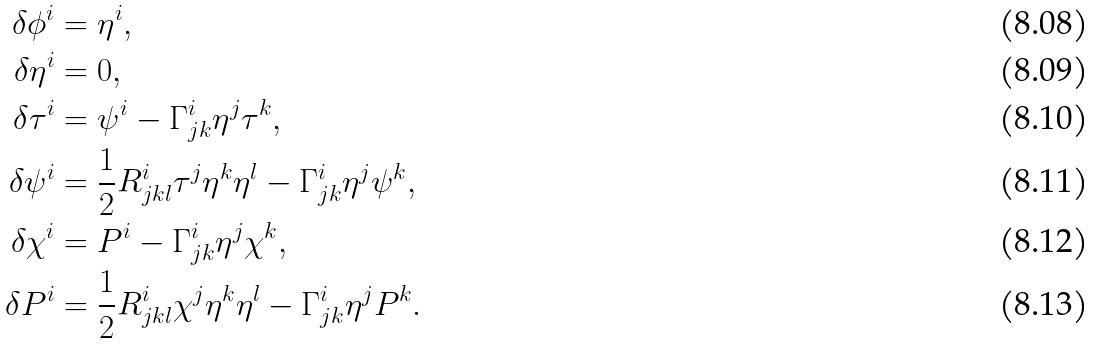<formula> <loc_0><loc_0><loc_500><loc_500>\delta \phi ^ { i } & = \eta ^ { i } , \\ \delta \eta ^ { i } & = 0 , \\ \delta \tau ^ { i } & = \psi ^ { i } - \Gamma ^ { i } _ { j k } \eta ^ { j } \tau ^ { k } , \\ \delta \psi ^ { i } & = \frac { 1 } { 2 } R ^ { i } _ { j k l } \tau ^ { j } \eta ^ { k } \eta ^ { l } - \Gamma ^ { i } _ { j k } \eta ^ { j } \psi ^ { k } , \\ \delta \chi ^ { i } & = P ^ { i } - \Gamma ^ { i } _ { j k } \eta ^ { j } \chi ^ { k } , \\ \delta P ^ { i } & = \frac { 1 } { 2 } R ^ { i } _ { j k l } \chi ^ { j } \eta ^ { k } \eta ^ { l } - \Gamma ^ { i } _ { j k } \eta ^ { j } P ^ { k } .</formula> 